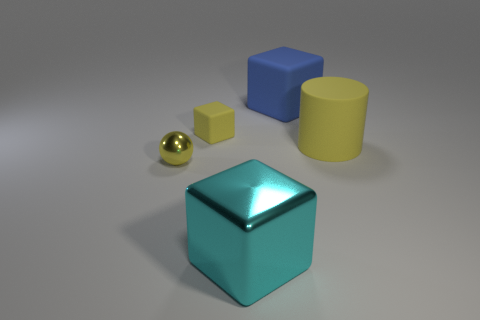Add 3 small yellow matte blocks. How many objects exist? 8 Subtract all cylinders. How many objects are left? 4 Subtract all tiny red matte balls. Subtract all large blue blocks. How many objects are left? 4 Add 5 big blue matte things. How many big blue matte things are left? 6 Add 4 yellow metal balls. How many yellow metal balls exist? 5 Subtract 1 yellow cubes. How many objects are left? 4 